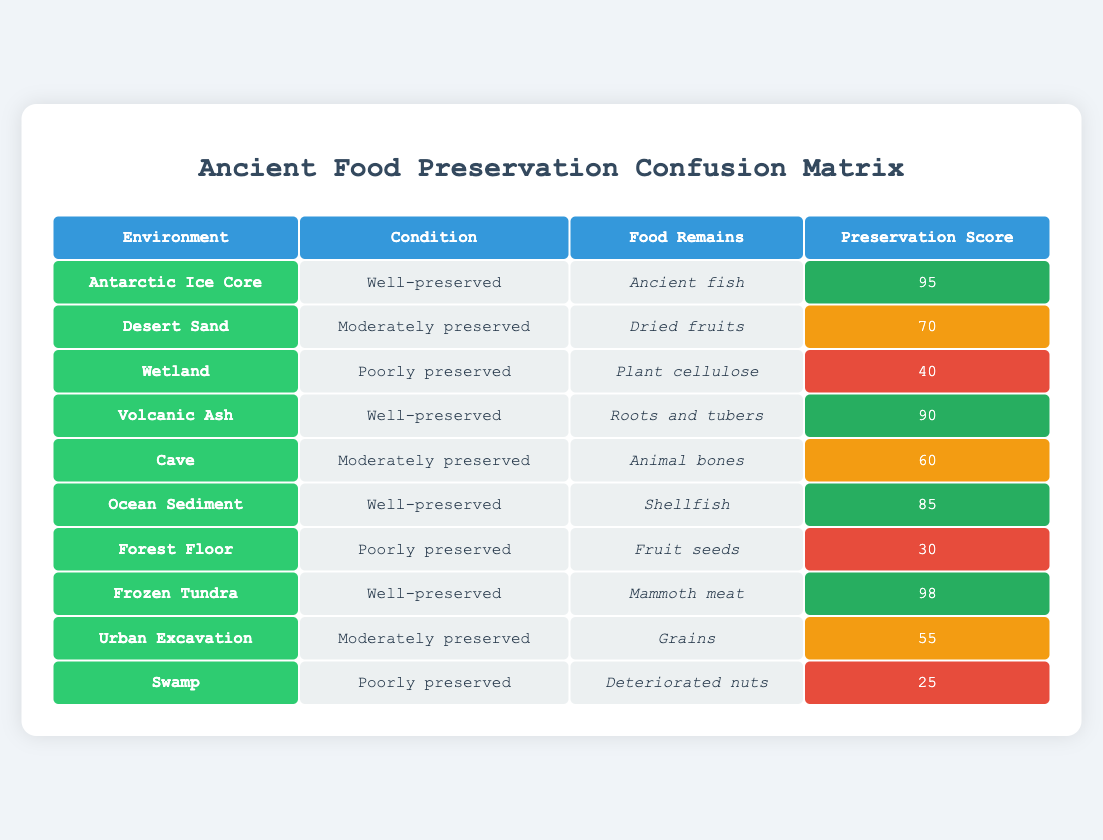What is the preservation score for Ancient fish in the Antarctic Ice Core? The table indicates that the preservation score for Ancient fish is explicitly listed next to the Antarctic Ice Core entry, which shows a score of 95.
Answer: 95 Which environment has the poorly preserved food remains of Fruit seeds? The row for the Forest Floor shows that it houses the food remains of Fruit seeds and indicates that they are poorly preserved.
Answer: Forest Floor What is the average preservation score for food remains labeled as "Well-preserved"? There are four entries classified as well-preserved: Ancient fish (95), Roots and tubers (90), Shellfish (85), and Mammoth meat (98). Summing these scores gives 95 + 90 + 85 + 98 = 368. The average score is calculated by dividing the sum by the number of entries: 368/4 = 92.
Answer: 92 Is it true that all food remains in the Desert Sand environment are moderately preserved? Yes, checking the row for Desert Sand indicates that the food remains, Dried fruits, are indeed categorized as moderately preserved.
Answer: Yes What is the difference in preservation scores between the best and worst preserved food remains? The best-preserved food remains, Mammoth meat in Frozen Tundra, have a score of 98, while the worst preserved, Deteriorated nuts in Swamp, have a score of 25. The difference is calculated as 98 - 25 = 73.
Answer: 73 Which environment has a better preservation score: Urban Excavation or Cave? The Urban Excavation has a preservation score of 55, and the Cave has a score of 60. A comparison shows that 60 (Cave) is greater than 55 (Urban Excavation), indicating the Cave has a better score.
Answer: Cave How many environments have food remains that were poorly preserved? Upon examining the table, entries for Wetland, Forest Floor, and Swamp indicate poorly preserved food remains. Counting these gives a total of three environments with poorly preserved remains.
Answer: 3 What type of food remains is found in Volcanic Ash? The table explicitly states that the food remains found in Volcanic Ash are Roots and tubers.
Answer: Roots and tubers Which environment has the highest preservation score and what is it? The Frozen Tundra has the highest preservation score of 98 for the food remains, Mammoth meat, as noted in the table.
Answer: Frozen Tundra, 98 